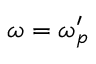Convert formula to latex. <formula><loc_0><loc_0><loc_500><loc_500>\omega = \omega _ { p } ^ { \prime }</formula> 